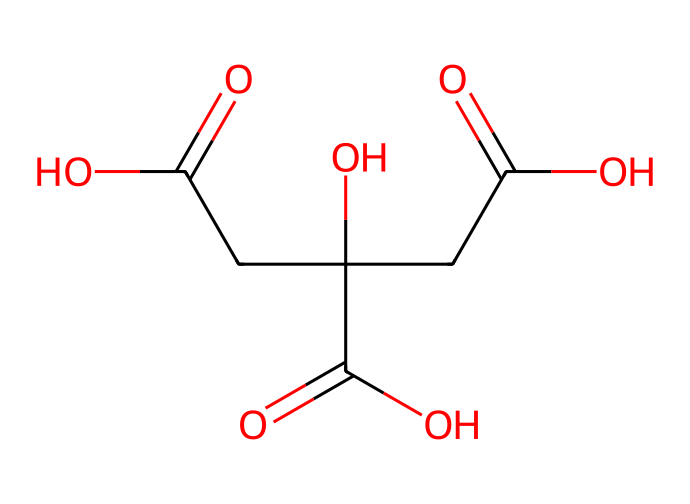How many carboxylic acid groups are present in citric acid? The chemical structure indicates three distinct -COOH groups. Each carboxylic acid group contributes to citric acid's classification as an acid.
Answer: three What is the total number of carbon atoms in citric acid? By analyzing the structure, there are a total of six carbon atoms present. Each carbon atom is counted in the main carbon skeleton and branches.
Answer: six Which functional group is responsible for the acidity of citric acid? The -COOH groups, known as carboxylic acid groups, donate protons, giving citric acid its acidic properties.
Answer: carboxylic acid What is the molecular formula of citric acid? From the SMILES representation, the molecular formula can be derived as C6H8O7, indicating the number of each type of atom present in the molecule.
Answer: C6H8O7 How many hydroxyl (-OH) groups are present in citric acid? The structure shows two -OH groups attached to the carbon skeleton, which are indicative of alcohol functionality.
Answer: two What type of chemical compound is citric acid? Given the presence of multiple carboxylic acid groups, citric acid is classified as a weak organic acid.
Answer: weak organic acid What does the presence of multiple carboxylic acid groups suggest about citric acid's properties? The presence of multiple -COOH groups suggests stronger acidity and a potential for multiple proton donations in solution, enhancing its effectiveness as a chelating agent.
Answer: stronger acidity 